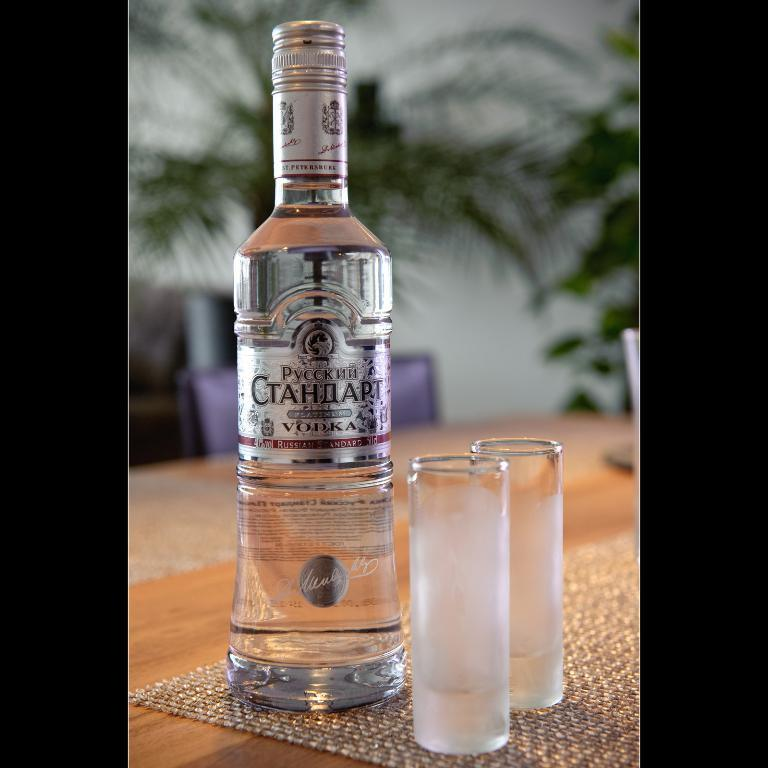<image>
Write a terse but informative summary of the picture. 40% Russian Standard Vodka in a clear bottle with 2 glass cups. 